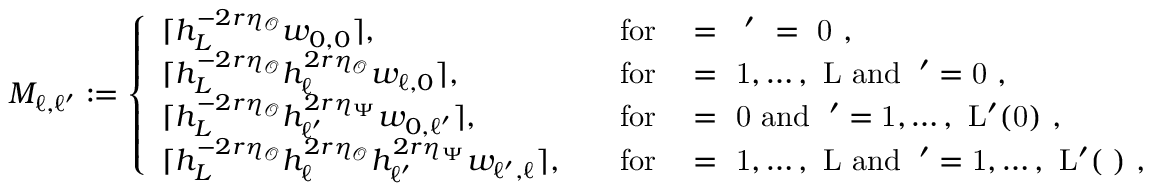Convert formula to latex. <formula><loc_0><loc_0><loc_500><loc_500>M _ { \ell , \ell ^ { \prime } } \colon = \left \{ \begin{array} { l l } { \lceil h _ { L } ^ { - 2 r \eta _ { \mathcal { O } } } w _ { 0 , 0 } \rceil , \quad } & { f o r \ell = \ell ^ { \prime } = 0 , } \\ { \lceil h _ { L } ^ { - 2 r \eta _ { \mathcal { O } } } h _ { \ell } ^ { 2 r \eta _ { \mathcal { O } } } w _ { \ell , 0 } \rceil , \quad } & { f o r \ell = 1 , \dots , L a n d \ell ^ { \prime } = 0 , } \\ { \lceil h _ { L } ^ { - 2 r \eta _ { \mathcal { O } } } h _ { \ell ^ { \prime } } ^ { 2 r \eta _ { \Psi } } w _ { 0 , \ell ^ { \prime } } \rceil , \quad } & { f o r \ell = 0 a n d \ell ^ { \prime } = 1 , \dots , L ^ { \prime } ( 0 ) , } \\ { \lceil h _ { L } ^ { - 2 r \eta _ { \mathcal { O } } } h _ { \ell } ^ { 2 r \eta _ { \mathcal { O } } } h _ { \ell ^ { \prime } } ^ { 2 r \eta _ { \Psi } } w _ { \ell ^ { \prime } , \ell } \rceil , \quad } & { f o r \ell = 1 , \dots , L a n d \ell ^ { \prime } = 1 , \dots , L ^ { \prime } ( \ell ) , } \end{array}</formula> 